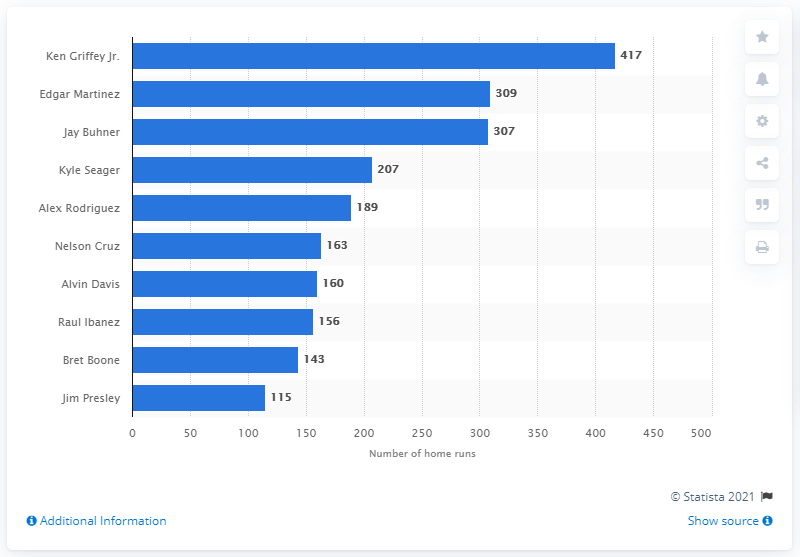Give some essential details in this illustration. In total, Junior has hit 417 home runs. 